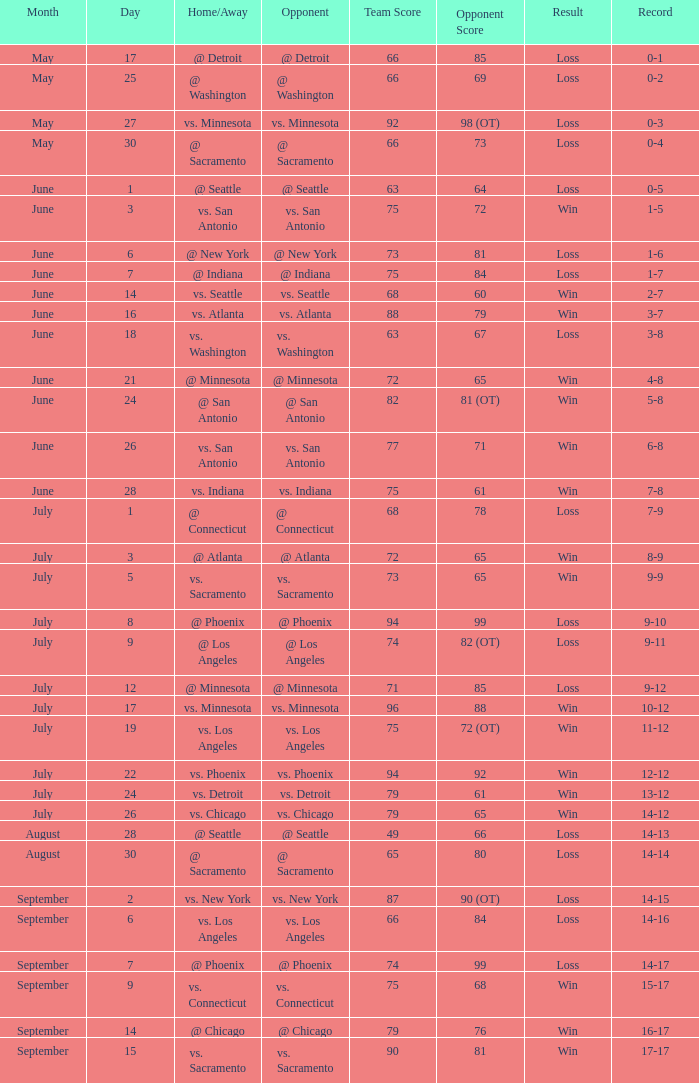What was the game's score when the record was 0-1? 66-85. 